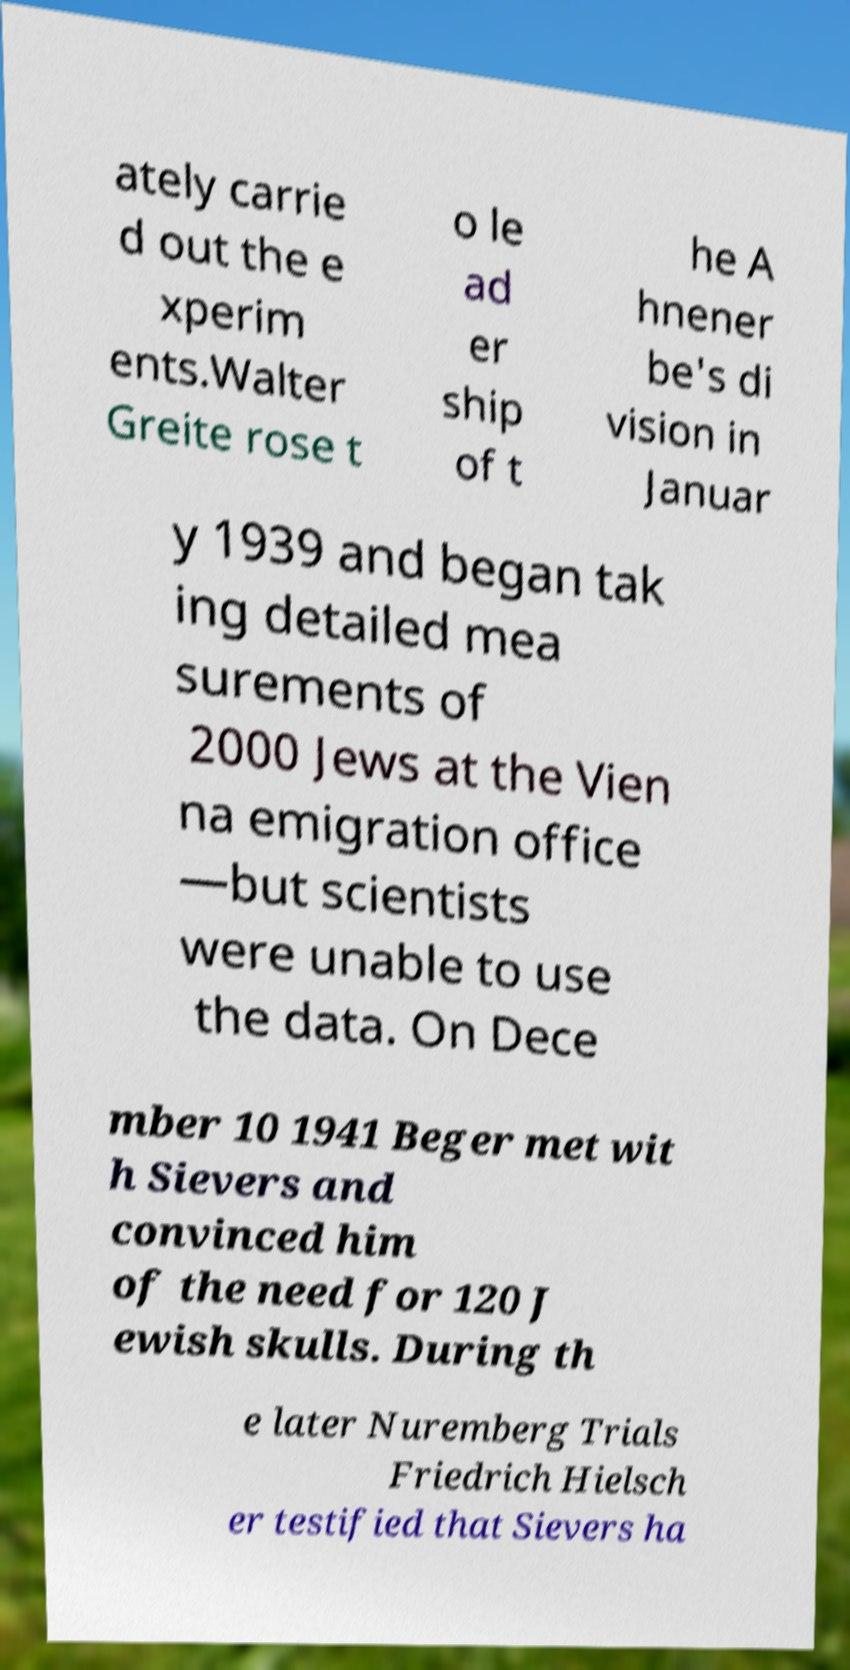Can you accurately transcribe the text from the provided image for me? ately carrie d out the e xperim ents.Walter Greite rose t o le ad er ship of t he A hnener be's di vision in Januar y 1939 and began tak ing detailed mea surements of 2000 Jews at the Vien na emigration office —but scientists were unable to use the data. On Dece mber 10 1941 Beger met wit h Sievers and convinced him of the need for 120 J ewish skulls. During th e later Nuremberg Trials Friedrich Hielsch er testified that Sievers ha 